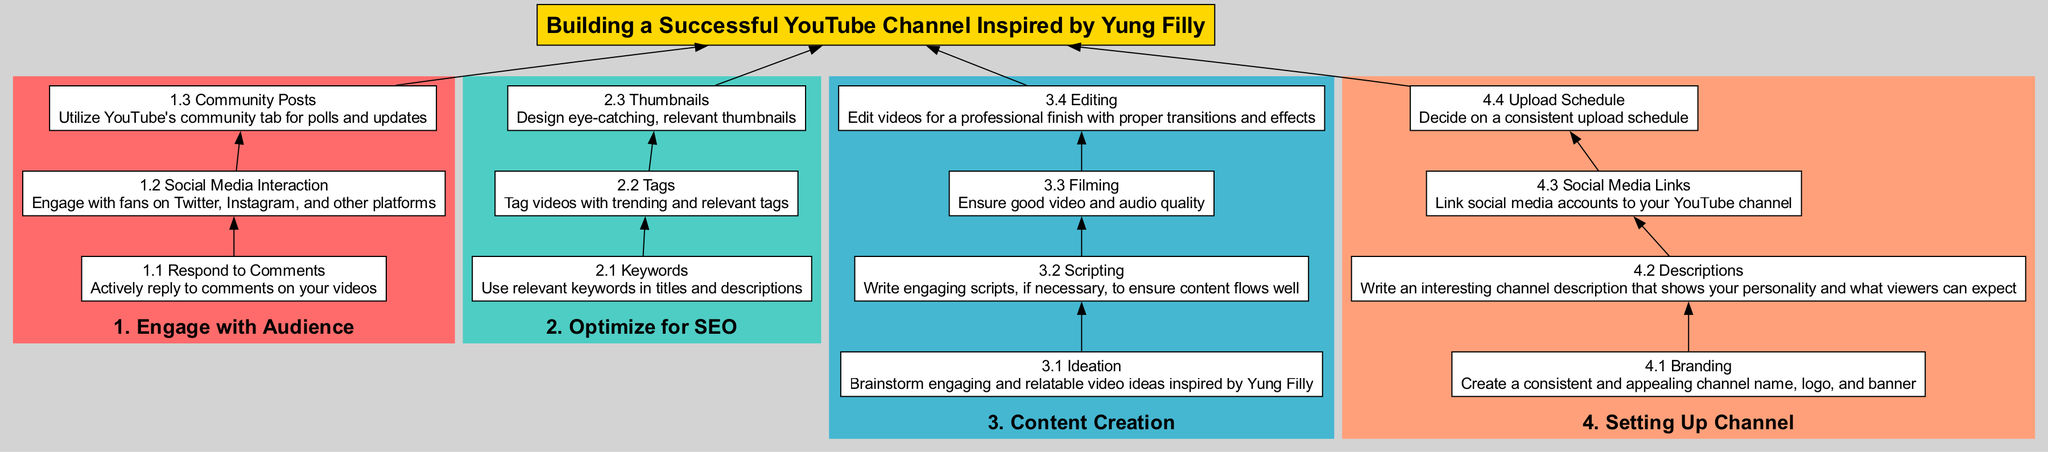What is the first step for building a YouTube channel? The first step in the flow chart is "Setting Up Channel," which is located at the bottom of the diagram.
Answer: Setting Up Channel How many main categories are there in the flow chart? The flow chart represents four main categories: Setting Up Channel, Content Creation, Optimize for SEO, and Engage with Audience. Counting these categories gives us four.
Answer: Four What is the purpose of "Social Media Interaction"? "Social Media Interaction" is a step under the "Engage with Audience" category and is described as engaging with fans on other platforms, emphasizing interaction beyond YouTube.
Answer: Engage with fans Which step follows "Editing" in the Content Creation category? In the "Content Creation" category, the step that follows "Editing" is not explicitly listed, but it concludes the sequence, which relates to finalizing video quality.
Answer: None What is the last step before "Engage with Audience"? The last step before "Engage with Audience" is "Optimize for SEO," so the answer involves finding the connection to the previous category directly linked to audience engagement.
Answer: Optimize for SEO How does "Thumbnails" contribute to SEO? "Thumbnails" is listed under "Optimize for SEO," and it suggests that designing eye-catching and relevant thumbnails helps attract viewers, positively influencing search engine optimization.
Answer: Attract viewers Which two steps are linked under the "Content Creation"? Under "Content Creation," the two linked steps that connect directly are "Scripting" and "Filming," as they are sequential actions taken when creating content.
Answer: Scripting and Filming What is the importance of a consistent upload schedule? A consistent upload schedule, found in "Setting Up Channel," helps in maintaining audience engagement and expectations, enhancing overall channel performance.
Answer: Maintain audience engagement What color represents the "Optimize for SEO" category? In the flow chart, "Optimize for SEO" is represented by the color that corresponds to the second main category in the visual hierarchy, which is colored differently from others.
Answer: Turquoise 